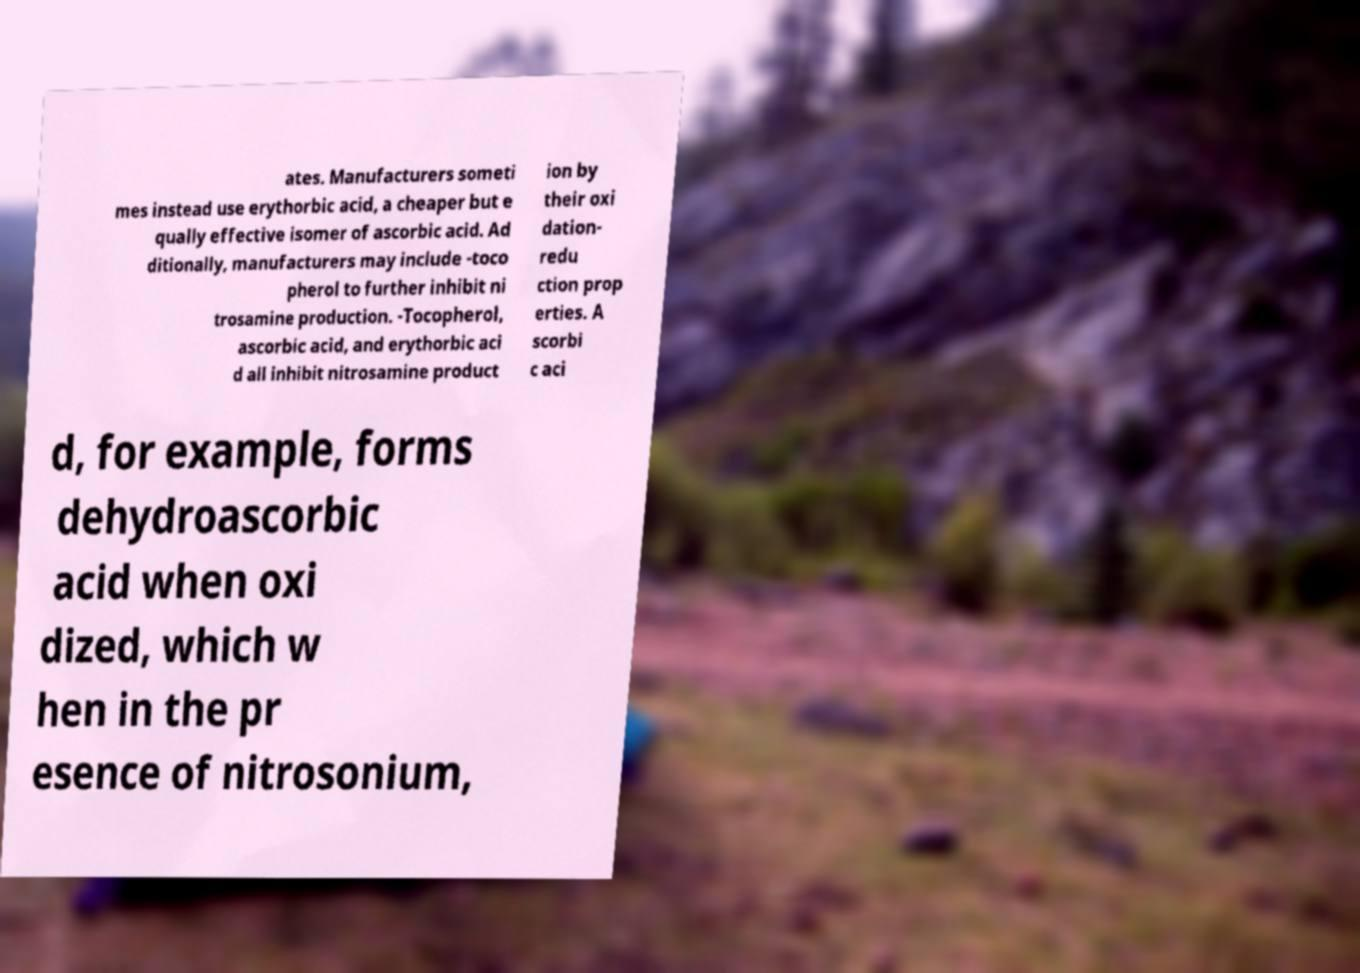For documentation purposes, I need the text within this image transcribed. Could you provide that? ates. Manufacturers someti mes instead use erythorbic acid, a cheaper but e qually effective isomer of ascorbic acid. Ad ditionally, manufacturers may include -toco pherol to further inhibit ni trosamine production. -Tocopherol, ascorbic acid, and erythorbic aci d all inhibit nitrosamine product ion by their oxi dation- redu ction prop erties. A scorbi c aci d, for example, forms dehydroascorbic acid when oxi dized, which w hen in the pr esence of nitrosonium, 